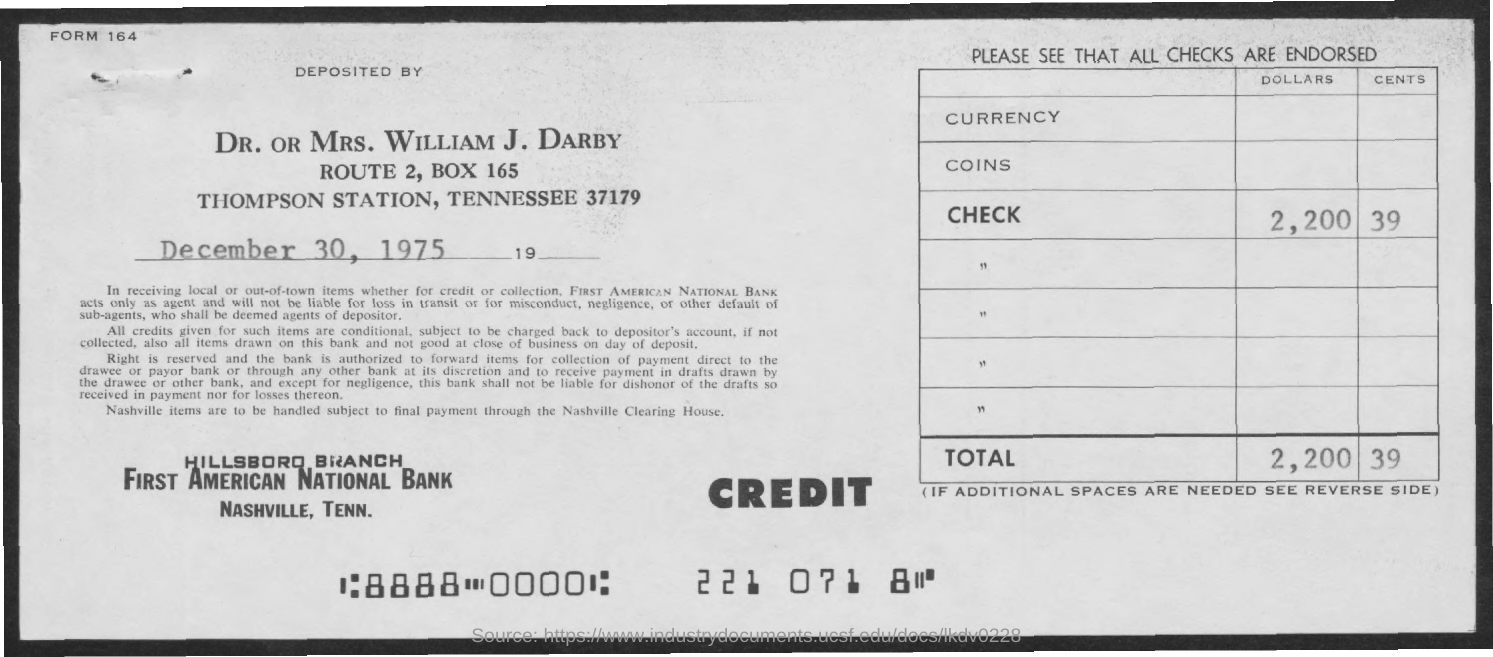Mention a couple of crucial points in this snapshot. The check amount is 2,200.39. The document was deposited by Dr. or Mrs. William J. Darby. The total amount is 2,200 with 39 cents. The date on the document is December 30, 1975. 